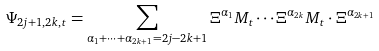Convert formula to latex. <formula><loc_0><loc_0><loc_500><loc_500>\Psi _ { 2 j + 1 , 2 k , t } = \sum _ { \alpha _ { 1 } + \cdots + \alpha _ { 2 k + 1 } = 2 j - 2 k + 1 } \Xi ^ { \alpha _ { 1 } } M _ { t } \cdots \Xi ^ { \alpha _ { 2 k } } M _ { t } \cdot \Xi ^ { \alpha _ { 2 k + 1 } }</formula> 